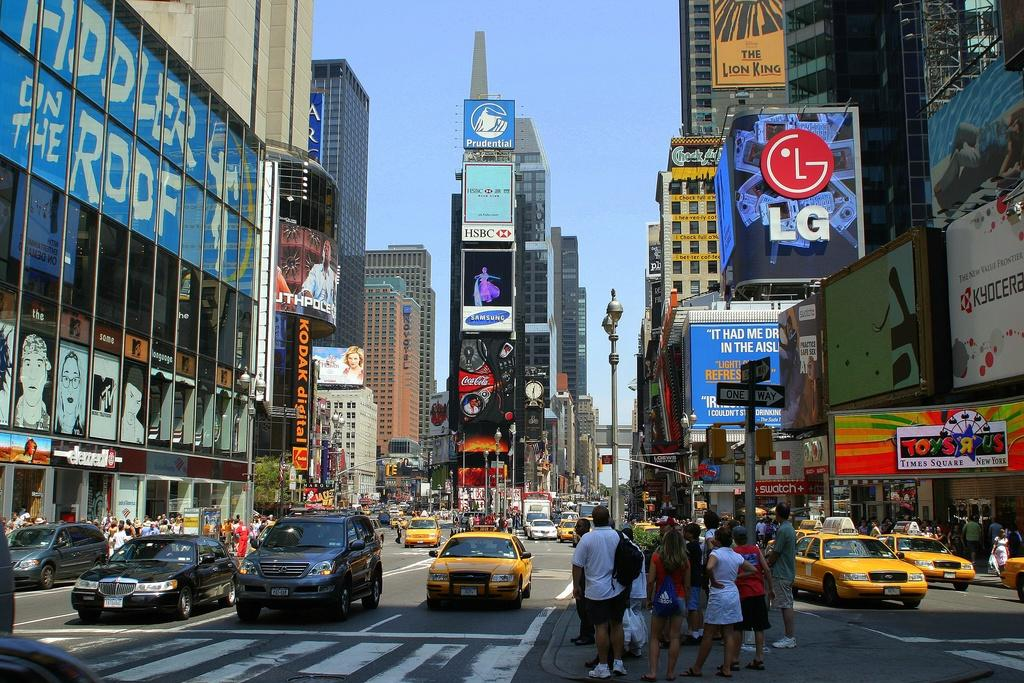Provide a one-sentence caption for the provided image. a sign above the street that says LG. 